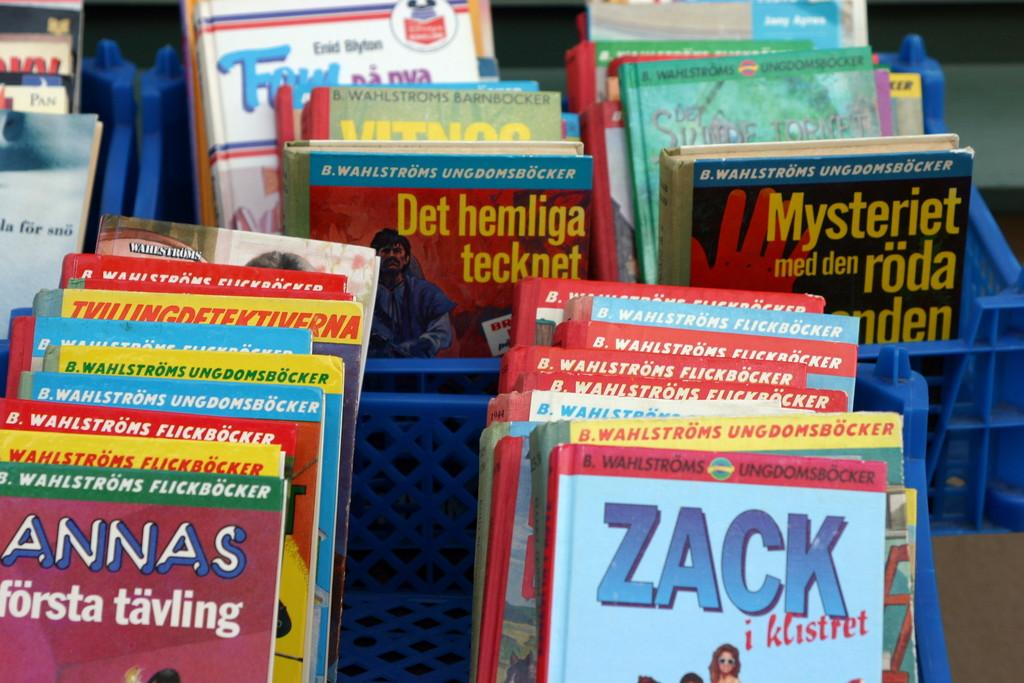<image>
Summarize the visual content of the image. A book titled " Zack" and a book titled Det Hemliga tecknet". 